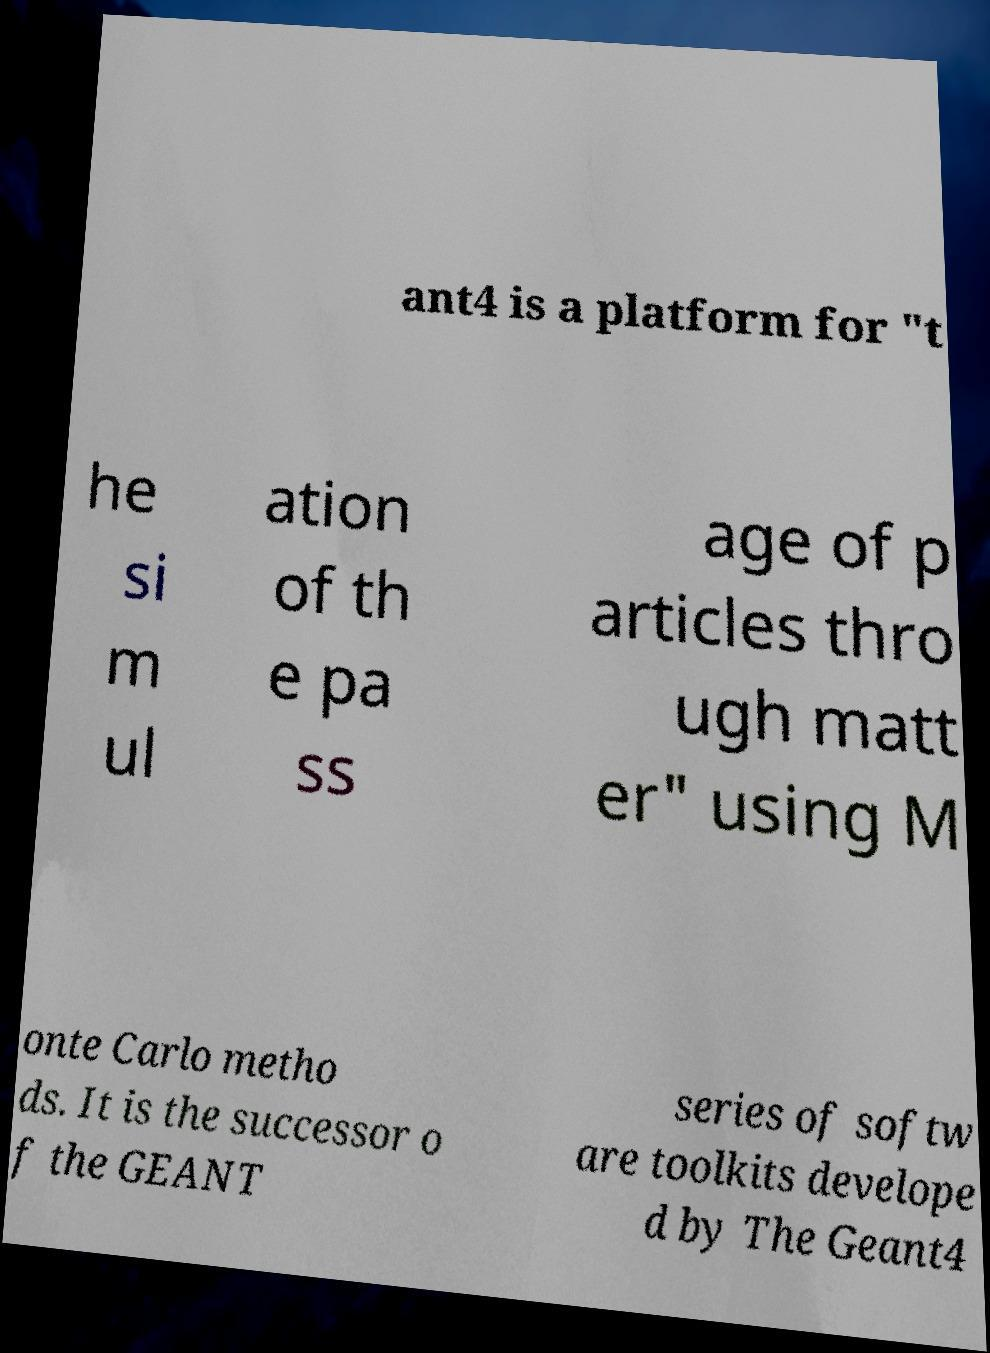I need the written content from this picture converted into text. Can you do that? ant4 is a platform for "t he si m ul ation of th e pa ss age of p articles thro ugh matt er" using M onte Carlo metho ds. It is the successor o f the GEANT series of softw are toolkits develope d by The Geant4 